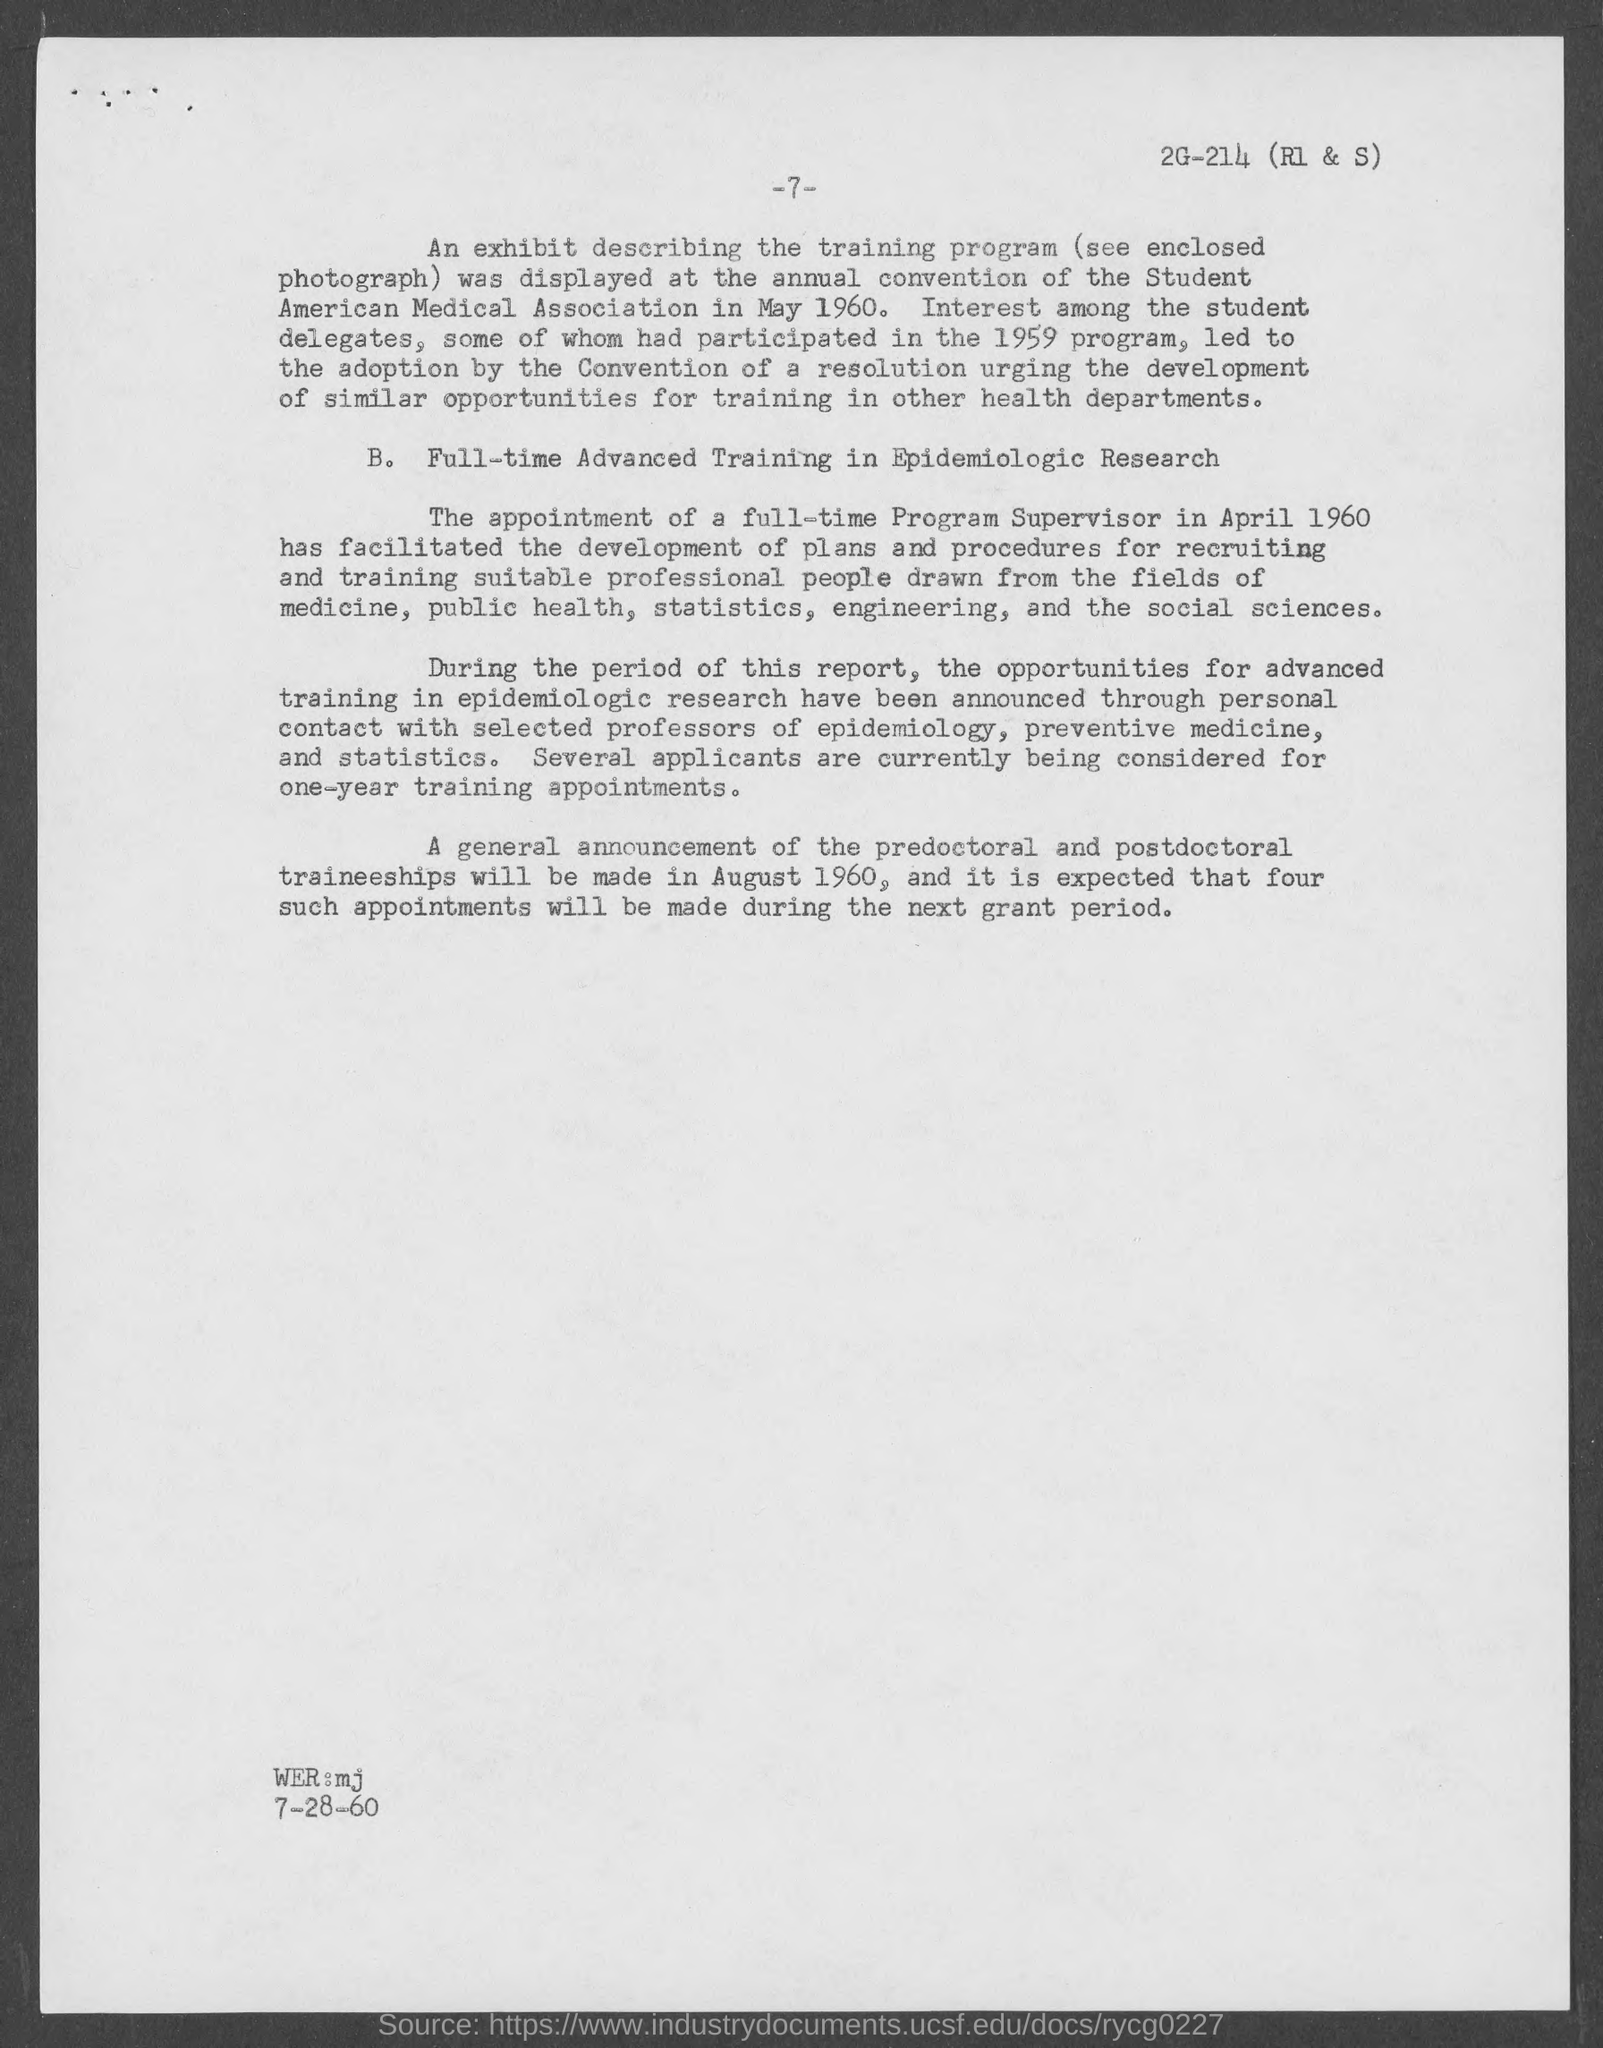When was the appointment of a full time program supervisor done?
Provide a short and direct response. APRIL 1960. When will a general announcement of the predoctoral ad postdoctoral traineeship be made?
Provide a succinct answer. August 1960. 